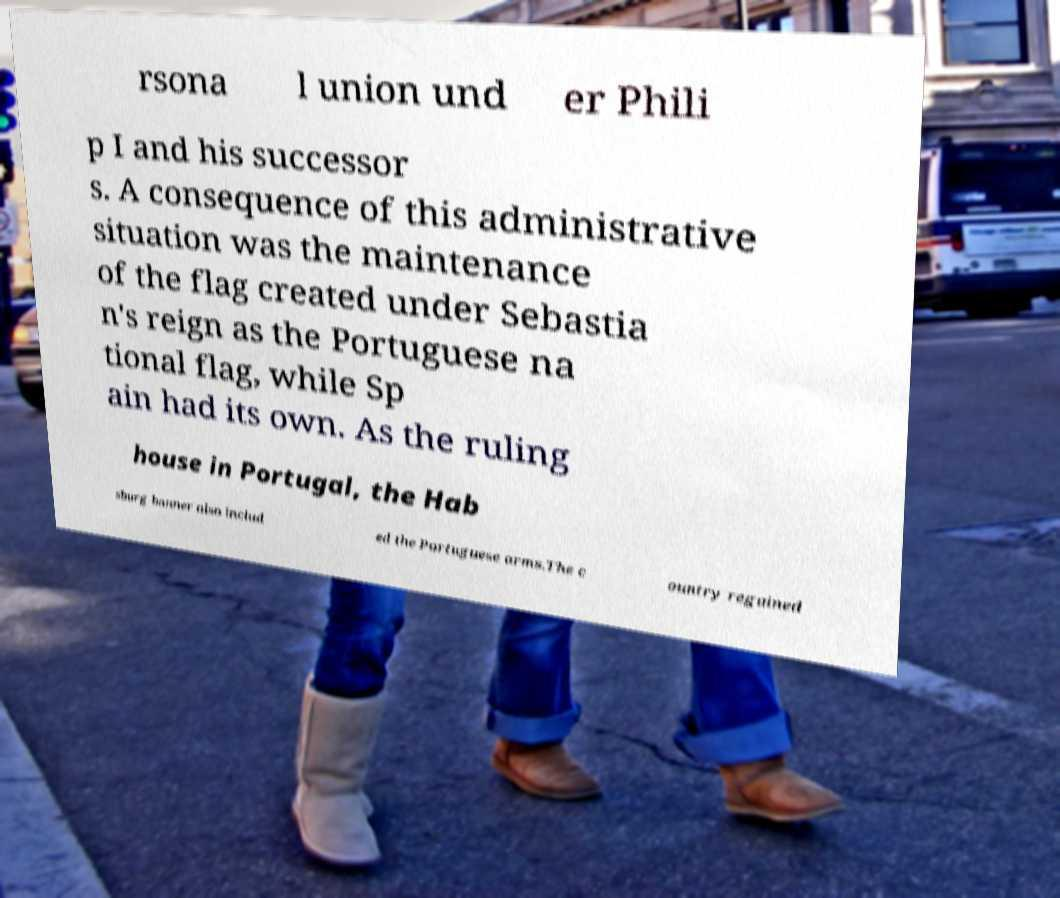What messages or text are displayed in this image? I need them in a readable, typed format. rsona l union und er Phili p I and his successor s. A consequence of this administrative situation was the maintenance of the flag created under Sebastia n's reign as the Portuguese na tional flag, while Sp ain had its own. As the ruling house in Portugal, the Hab sburg banner also includ ed the Portuguese arms.The c ountry regained 